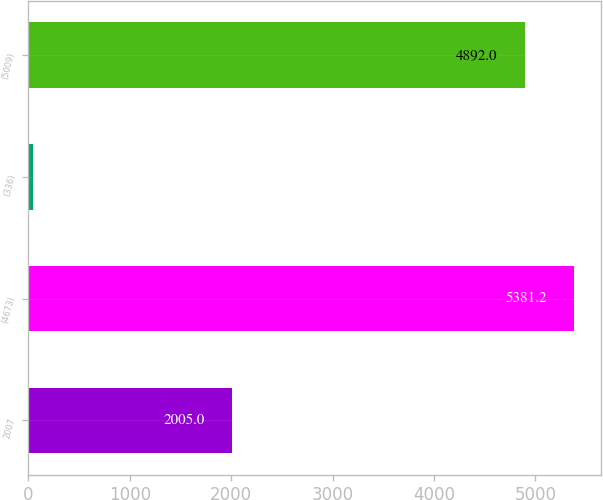Convert chart to OTSL. <chart><loc_0><loc_0><loc_500><loc_500><bar_chart><fcel>2007<fcel>(4673)<fcel>(336)<fcel>(5009)<nl><fcel>2005<fcel>5381.2<fcel>45<fcel>4892<nl></chart> 